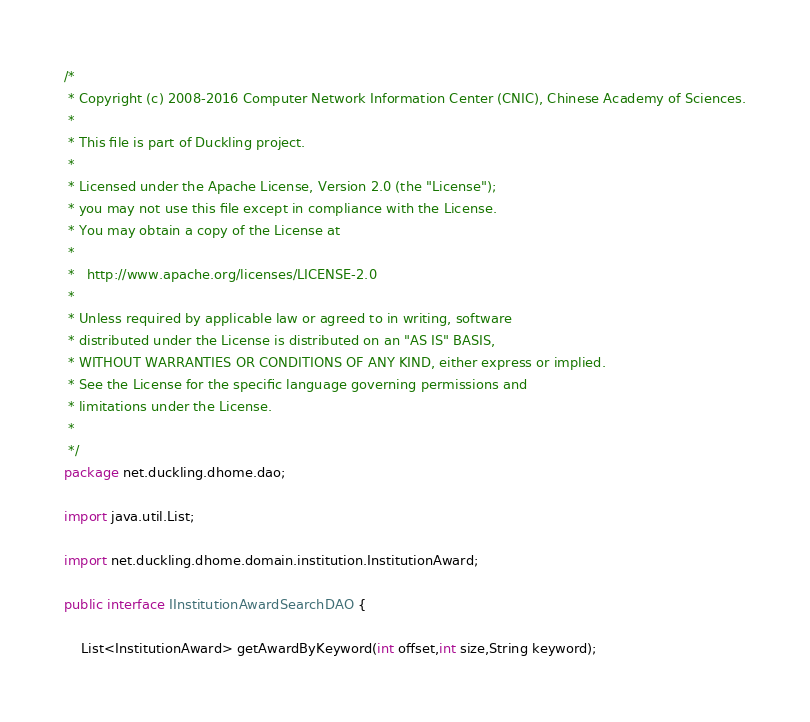Convert code to text. <code><loc_0><loc_0><loc_500><loc_500><_Java_>/*
 * Copyright (c) 2008-2016 Computer Network Information Center (CNIC), Chinese Academy of Sciences.
 * 
 * This file is part of Duckling project.
 *
 * Licensed under the Apache License, Version 2.0 (the "License");
 * you may not use this file except in compliance with the License.
 * You may obtain a copy of the License at
 *
 *   http://www.apache.org/licenses/LICENSE-2.0
 *
 * Unless required by applicable law or agreed to in writing, software
 * distributed under the License is distributed on an "AS IS" BASIS,
 * WITHOUT WARRANTIES OR CONDITIONS OF ANY KIND, either express or implied.
 * See the License for the specific language governing permissions and
 * limitations under the License. 
 *
 */
package net.duckling.dhome.dao;

import java.util.List;

import net.duckling.dhome.domain.institution.InstitutionAward;

public interface IInstitutionAwardSearchDAO {

	List<InstitutionAward> getAwardByKeyword(int offset,int size,String keyword);</code> 